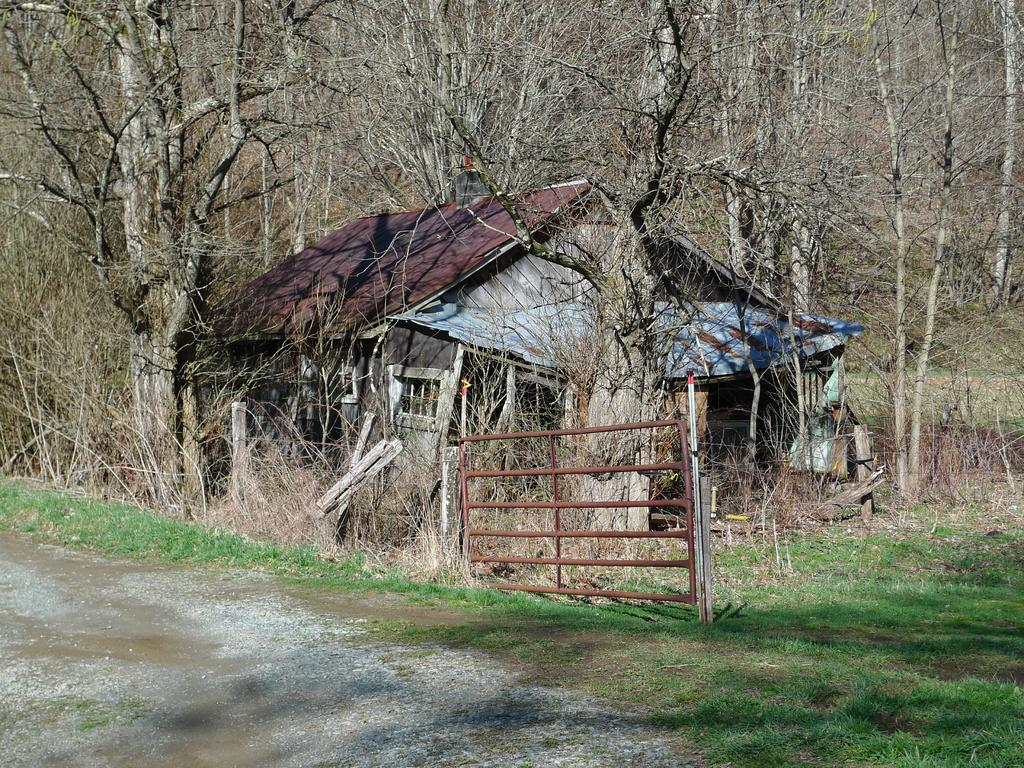What is the main structure in the center of the image? There is a gate in the center of the image. What type of building can be seen in the image? There is a building with a roof in the image. What can be seen in the background of the image? There is a group of trees in the background of the image. What is the acoustics like in the building in the image? There is no information provided about the acoustics in the building, so it cannot be determined from the image. 